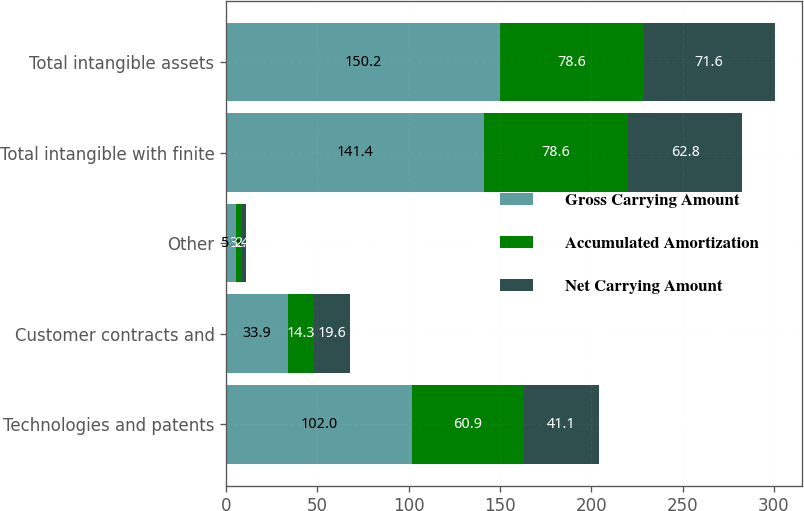Convert chart. <chart><loc_0><loc_0><loc_500><loc_500><stacked_bar_chart><ecel><fcel>Technologies and patents<fcel>Customer contracts and<fcel>Other<fcel>Total intangible with finite<fcel>Total intangible assets<nl><fcel>Gross Carrying Amount<fcel>102<fcel>33.9<fcel>5.5<fcel>141.4<fcel>150.2<nl><fcel>Accumulated Amortization<fcel>60.9<fcel>14.3<fcel>3.4<fcel>78.6<fcel>78.6<nl><fcel>Net Carrying Amount<fcel>41.1<fcel>19.6<fcel>2.1<fcel>62.8<fcel>71.6<nl></chart> 